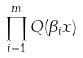Convert formula to latex. <formula><loc_0><loc_0><loc_500><loc_500>\prod _ { i = 1 } ^ { m } Q ( \beta _ { i } x )</formula> 